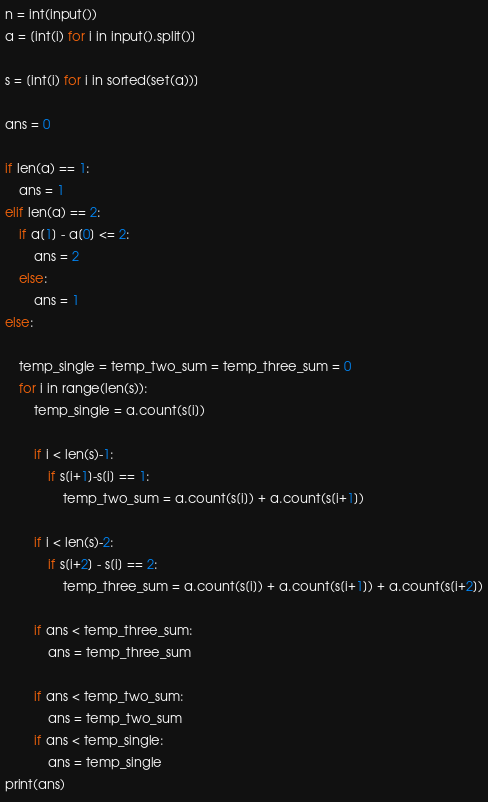Convert code to text. <code><loc_0><loc_0><loc_500><loc_500><_Python_>n = int(input())
a = [int(i) for i in input().split()]

s = [int(i) for i in sorted(set(a))]

ans = 0

if len(a) == 1:
    ans = 1
elif len(a) == 2:
    if a[1] - a[0] <= 2:
        ans = 2
    else:
        ans = 1
else:
    
    temp_single = temp_two_sum = temp_three_sum = 0
    for i in range(len(s)):
        temp_single = a.count(s[i])
        
        if i < len(s)-1:
            if s[i+1]-s[i] == 1:
                temp_two_sum = a.count(s[i]) + a.count(s[i+1])
                
        if i < len(s)-2:
            if s[i+2] - s[i] == 2:
                temp_three_sum = a.count(s[i]) + a.count(s[i+1]) + a.count(s[i+2])
        
        if ans < temp_three_sum:
            ans = temp_three_sum
        
        if ans < temp_two_sum:
            ans = temp_two_sum
        if ans < temp_single:
            ans = temp_single
print(ans)</code> 